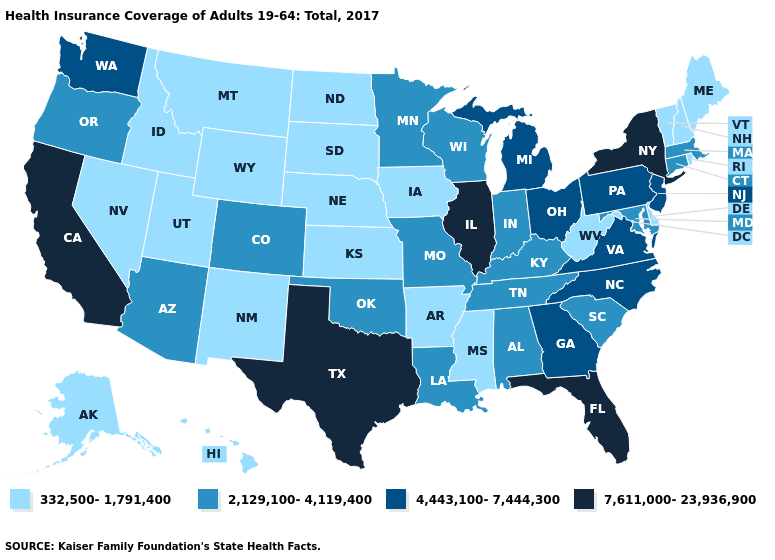Does Mississippi have the highest value in the USA?
Write a very short answer. No. Name the states that have a value in the range 332,500-1,791,400?
Be succinct. Alaska, Arkansas, Delaware, Hawaii, Idaho, Iowa, Kansas, Maine, Mississippi, Montana, Nebraska, Nevada, New Hampshire, New Mexico, North Dakota, Rhode Island, South Dakota, Utah, Vermont, West Virginia, Wyoming. Among the states that border North Carolina , does South Carolina have the highest value?
Concise answer only. No. What is the highest value in states that border Washington?
Answer briefly. 2,129,100-4,119,400. Name the states that have a value in the range 4,443,100-7,444,300?
Give a very brief answer. Georgia, Michigan, New Jersey, North Carolina, Ohio, Pennsylvania, Virginia, Washington. Name the states that have a value in the range 2,129,100-4,119,400?
Answer briefly. Alabama, Arizona, Colorado, Connecticut, Indiana, Kentucky, Louisiana, Maryland, Massachusetts, Minnesota, Missouri, Oklahoma, Oregon, South Carolina, Tennessee, Wisconsin. Which states have the lowest value in the MidWest?
Quick response, please. Iowa, Kansas, Nebraska, North Dakota, South Dakota. What is the value of North Carolina?
Write a very short answer. 4,443,100-7,444,300. Among the states that border Virginia , which have the lowest value?
Quick response, please. West Virginia. What is the highest value in the MidWest ?
Answer briefly. 7,611,000-23,936,900. Which states have the lowest value in the West?
Give a very brief answer. Alaska, Hawaii, Idaho, Montana, Nevada, New Mexico, Utah, Wyoming. Name the states that have a value in the range 4,443,100-7,444,300?
Concise answer only. Georgia, Michigan, New Jersey, North Carolina, Ohio, Pennsylvania, Virginia, Washington. Does Idaho have the lowest value in the West?
Keep it brief. Yes. What is the lowest value in the Northeast?
Be succinct. 332,500-1,791,400. What is the value of Maine?
Give a very brief answer. 332,500-1,791,400. 